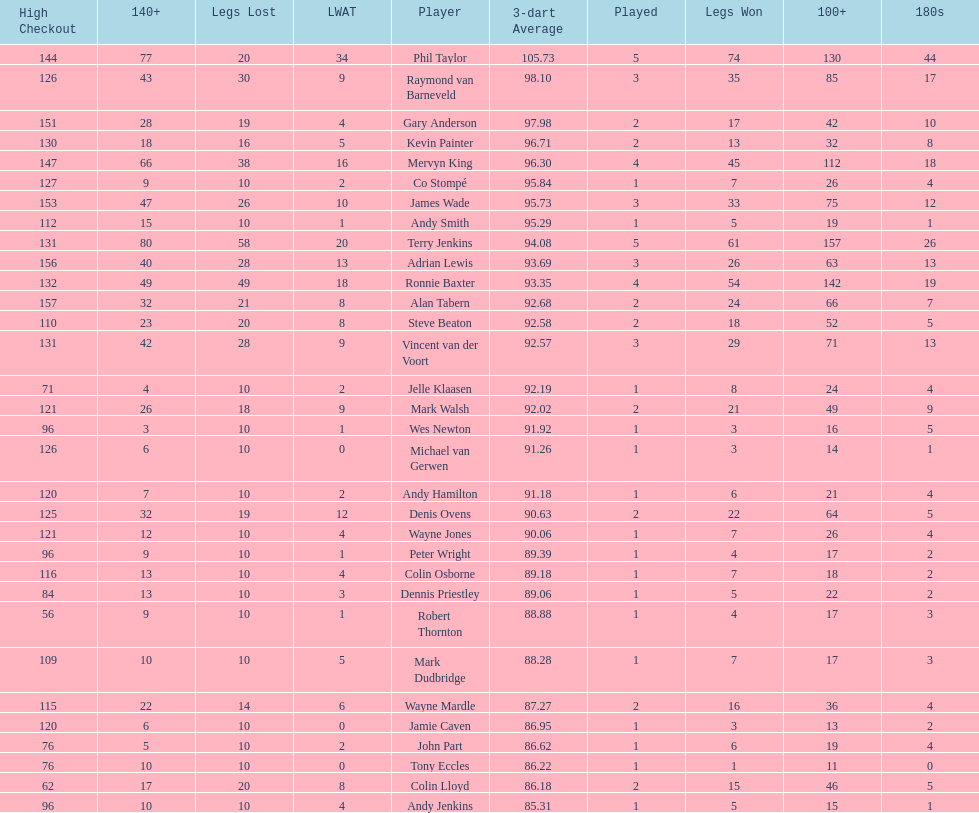Who won the highest number of legs in the 2009 world matchplay? Phil Taylor. 